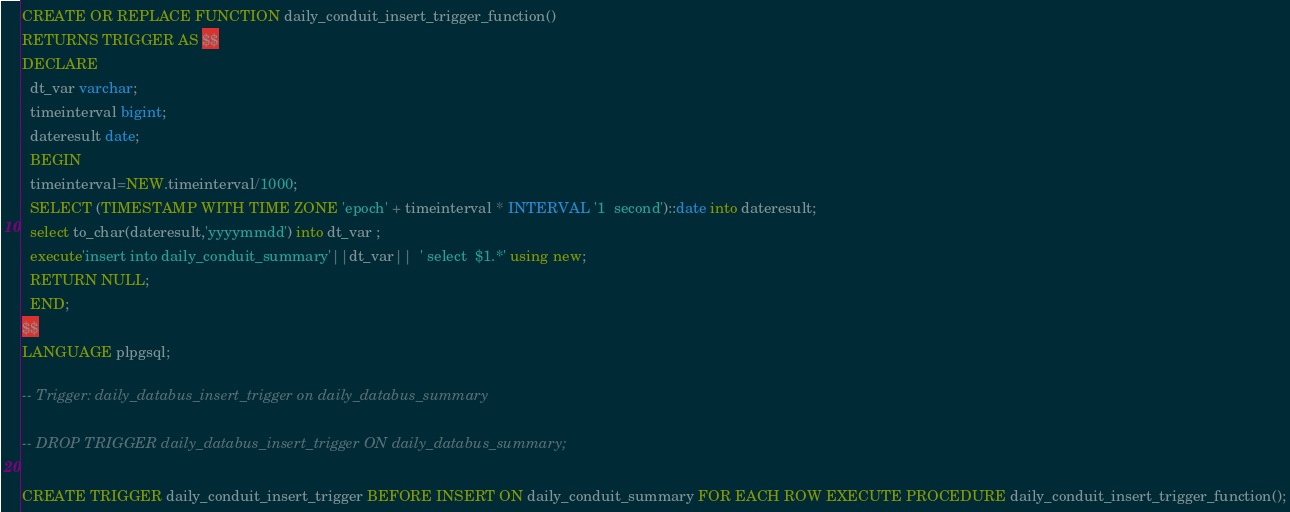<code> <loc_0><loc_0><loc_500><loc_500><_SQL_>
CREATE OR REPLACE FUNCTION daily_conduit_insert_trigger_function()
RETURNS TRIGGER AS $$
DECLARE                                                                                                 
  dt_var varchar;                                                                                        
  timeinterval bigint;                                                                                   
  dateresult date;                                                                                       
  BEGIN                                                                                                  
  timeinterval=NEW.timeinterval/1000;                                                                    
  SELECT (TIMESTAMP WITH TIME ZONE 'epoch' + timeinterval * INTERVAL '1  second')::date into dateresult; 
  select to_char(dateresult,'yyyymmdd') into dt_var ;                                                    
  execute'insert into daily_conduit_summary'||dt_var||  ' select  $1.*' using new;                       
  RETURN NULL;                                                                                           
  END;      
$$
LANGUAGE plpgsql;

-- Trigger: daily_databus_insert_trigger on daily_databus_summary

-- DROP TRIGGER daily_databus_insert_trigger ON daily_databus_summary;

CREATE TRIGGER daily_conduit_insert_trigger BEFORE INSERT ON daily_conduit_summary FOR EACH ROW EXECUTE PROCEDURE daily_conduit_insert_trigger_function();
</code> 